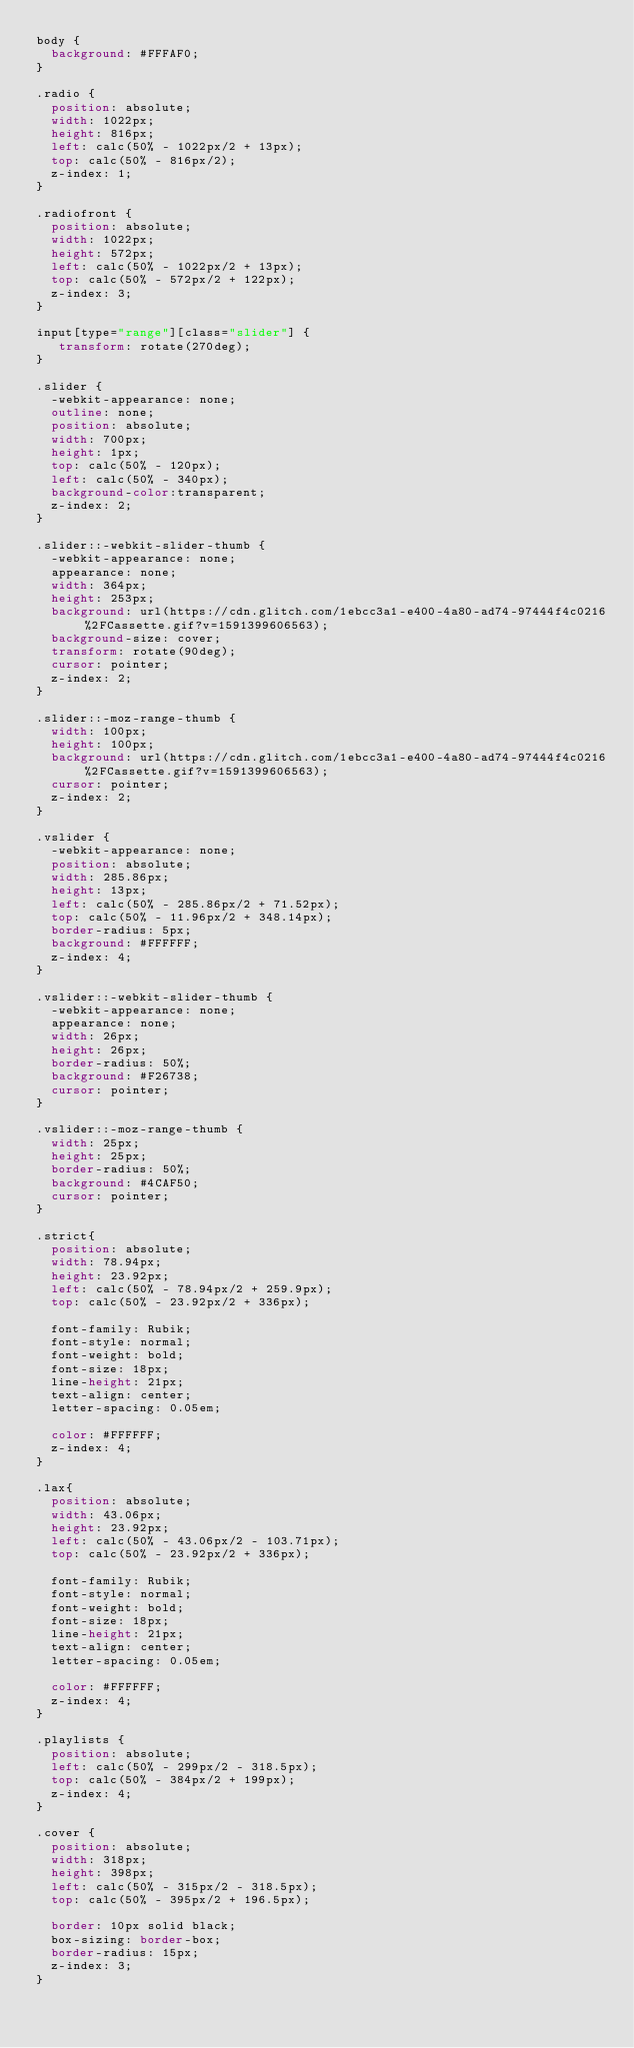Convert code to text. <code><loc_0><loc_0><loc_500><loc_500><_CSS_>body {
  background: #FFFAF0;
}

.radio {
  position: absolute;
  width: 1022px;
  height: 816px;
  left: calc(50% - 1022px/2 + 13px);
  top: calc(50% - 816px/2);
  z-index: 1;
}

.radiofront {
  position: absolute;
  width: 1022px;
  height: 572px;
  left: calc(50% - 1022px/2 + 13px);
  top: calc(50% - 572px/2 + 122px);
  z-index: 3;
}

input[type="range"][class="slider"] {
   transform: rotate(270deg);
}

.slider {
  -webkit-appearance: none;
  outline: none;
  position: absolute;
  width: 700px;
  height: 1px;
  top: calc(50% - 120px);
  left: calc(50% - 340px);
  background-color:transparent;
  z-index: 2;
}

.slider::-webkit-slider-thumb {
  -webkit-appearance: none;
  appearance: none;
  width: 364px;
  height: 253px;
  background: url(https://cdn.glitch.com/1ebcc3a1-e400-4a80-ad74-97444f4c0216%2FCassette.gif?v=1591399606563);
  background-size: cover;
  transform: rotate(90deg);
  cursor: pointer;
  z-index: 2;
}

.slider::-moz-range-thumb {
  width: 100px;
  height: 100px;
  background: url(https://cdn.glitch.com/1ebcc3a1-e400-4a80-ad74-97444f4c0216%2FCassette.gif?v=1591399606563);
  cursor: pointer;
  z-index: 2;
}

.vslider {
  -webkit-appearance: none;
  position: absolute;
  width: 285.86px;
  height: 13px;
  left: calc(50% - 285.86px/2 + 71.52px);
  top: calc(50% - 11.96px/2 + 348.14px);
  border-radius: 5px;
  background: #FFFFFF;
  z-index: 4;
}

.vslider::-webkit-slider-thumb {
  -webkit-appearance: none;
  appearance: none;
  width: 26px;
  height: 26px;
  border-radius: 50%;
  background: #F26738;
  cursor: pointer;
}

.vslider::-moz-range-thumb {
  width: 25px;
  height: 25px;
  border-radius: 50%;
  background: #4CAF50;
  cursor: pointer;
}

.strict{
  position: absolute;
  width: 78.94px;
  height: 23.92px;
  left: calc(50% - 78.94px/2 + 259.9px);
  top: calc(50% - 23.92px/2 + 336px);

  font-family: Rubik;
  font-style: normal;
  font-weight: bold;
  font-size: 18px;
  line-height: 21px;
  text-align: center;
  letter-spacing: 0.05em;

  color: #FFFFFF;
  z-index: 4;
}

.lax{
  position: absolute;
  width: 43.06px;
  height: 23.92px;
  left: calc(50% - 43.06px/2 - 103.71px);
  top: calc(50% - 23.92px/2 + 336px);

  font-family: Rubik;
  font-style: normal;
  font-weight: bold;
  font-size: 18px;
  line-height: 21px;
  text-align: center;
  letter-spacing: 0.05em;

  color: #FFFFFF;
  z-index: 4;
}

.playlists {
  position: absolute;
  left: calc(50% - 299px/2 - 318.5px);
  top: calc(50% - 384px/2 + 199px);
  z-index: 4;
}

.cover {
  position: absolute;
  width: 318px;
  height: 398px;
  left: calc(50% - 315px/2 - 318.5px);
  top: calc(50% - 395px/2 + 196.5px);

  border: 10px solid black;
  box-sizing: border-box;
  border-radius: 15px;
  z-index: 3;
}
</code> 